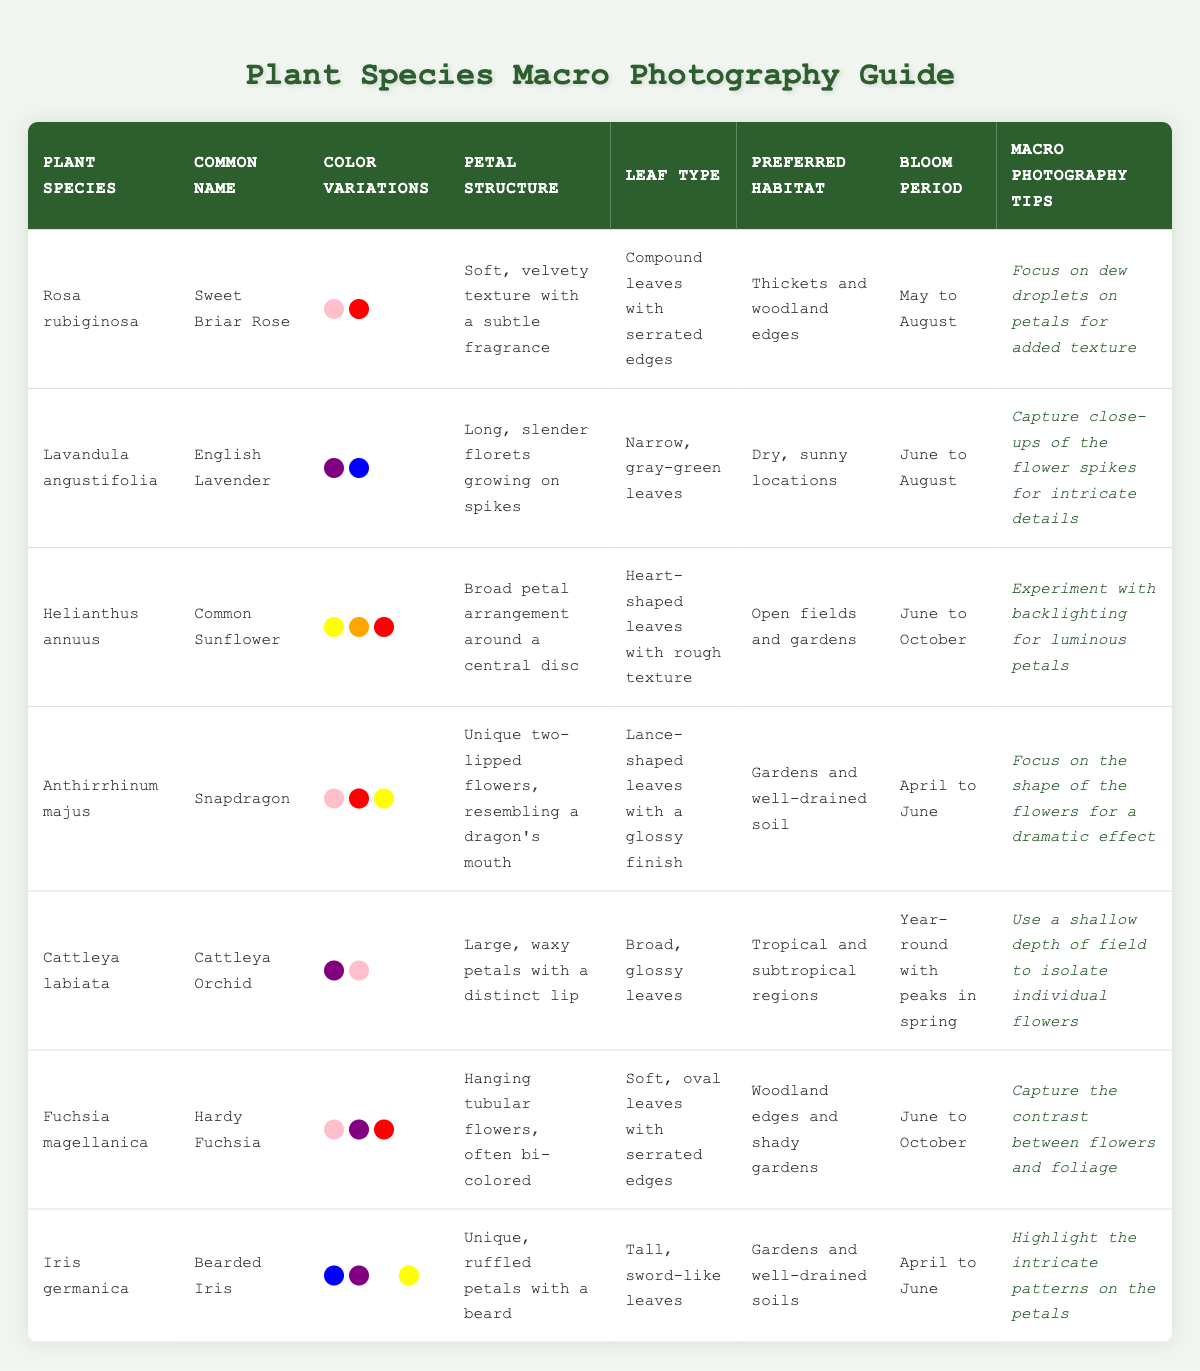What are the color variations for Cattleya labiata? The table lists the color variations for Cattleya labiata as Purple, Pink, and White, found in the respective row.
Answer: Purple, Pink, White Which plant species has a bloom period from April to June? By examining the bloom periods in the table, Snapdragon and Bearded Iris both have the same bloom period of April to June.
Answer: Snapdragon, Bearded Iris What is the preferred habitat for Helianthus annuus? Looking at the table, Helianthus annuus is listed with the preferred habitat of open fields and gardens in its row.
Answer: Open fields and gardens How many color variations does Fuchsia magellanica have? Fuchsia magellanica has three color variations listed: Pink, Purple, and Red. This can be counted directly from the table data.
Answer: 3 Is the petal structure of Rosa rubiginosa soft and velvety? The table specifies that the petal structure for Rosa rubiginosa is indeed soft and velvety, confirming this statement as true.
Answer: Yes Which plant species has the broadest petal structure? By comparing the petal structures, Helianthus annuus has the broad petal arrangement around a central disc, making it the broadest in the table.
Answer: Helianthus annuus What is the common name of Iris germanica? The common name of Iris germanica is stated in the table as Bearded Iris.
Answer: Bearded Iris Do all the plants listed have a bloom period in the summer? Examining the bloom periods reveals that not all plants bloom in summer; for example, Cattleya labiata blooms year-round, indicating that the statement is false.
Answer: No How many plant species bloom from June to August? The table identifies three plants that bloom during June to August: English Lavender, Common Sunflower, and Hardy Fuchsia. Adding these gives a total of three species.
Answer: 3 Which plant is preferred in dry, sunny locations? From the table, English Lavender is specified to prefer dry, sunny locations as its habitat.
Answer: English Lavender What is the macro photography tip for capturing the Bearded Iris? According to the table, the macro photography tip for Bearded Iris is to highlight the intricate patterns on the petals, as specified in its row.
Answer: Highlight intricate patterns on petals How many color variations are found in the plant species with the highest number of color variations? By reviewing the color variations, Snapdragon has four color variations (Pink, Red, Yellow, White), which is the highest; therefore, the answer is four.
Answer: 4 Is there a plant that has a bloom period extending beyond summer? Yes, the table indicates that Cattleya labiata has a bloom period that extends year-round, confirming the existence of such a plant.
Answer: Yes What type of leaves does Lavandula angustifolia have? According to the table, Lavandula angustifolia has narrow, gray-green leaves as listed in its row.
Answer: Narrow, gray-green leaves 